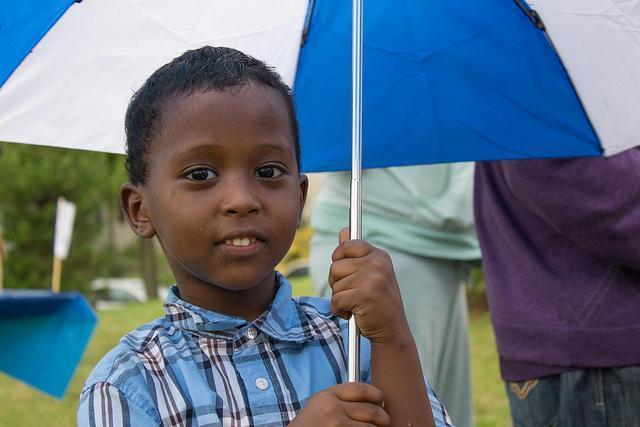How many boys are in the photo?
Give a very brief answer. 1. How many people are visible?
Give a very brief answer. 3. 